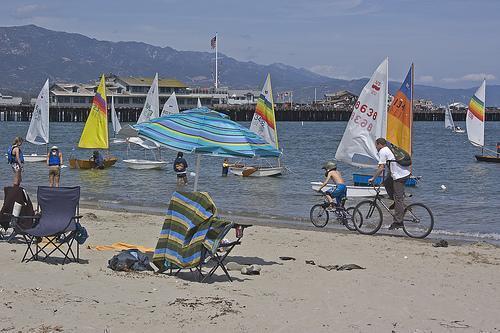How many people are on bikes?
Give a very brief answer. 2. How many sailboats are pictured?
Give a very brief answer. 11. How many bicycles are in the photo?
Give a very brief answer. 2. How many people are riding bikes?
Give a very brief answer. 2. How many yellow sails are in the picture?
Give a very brief answer. 1. 